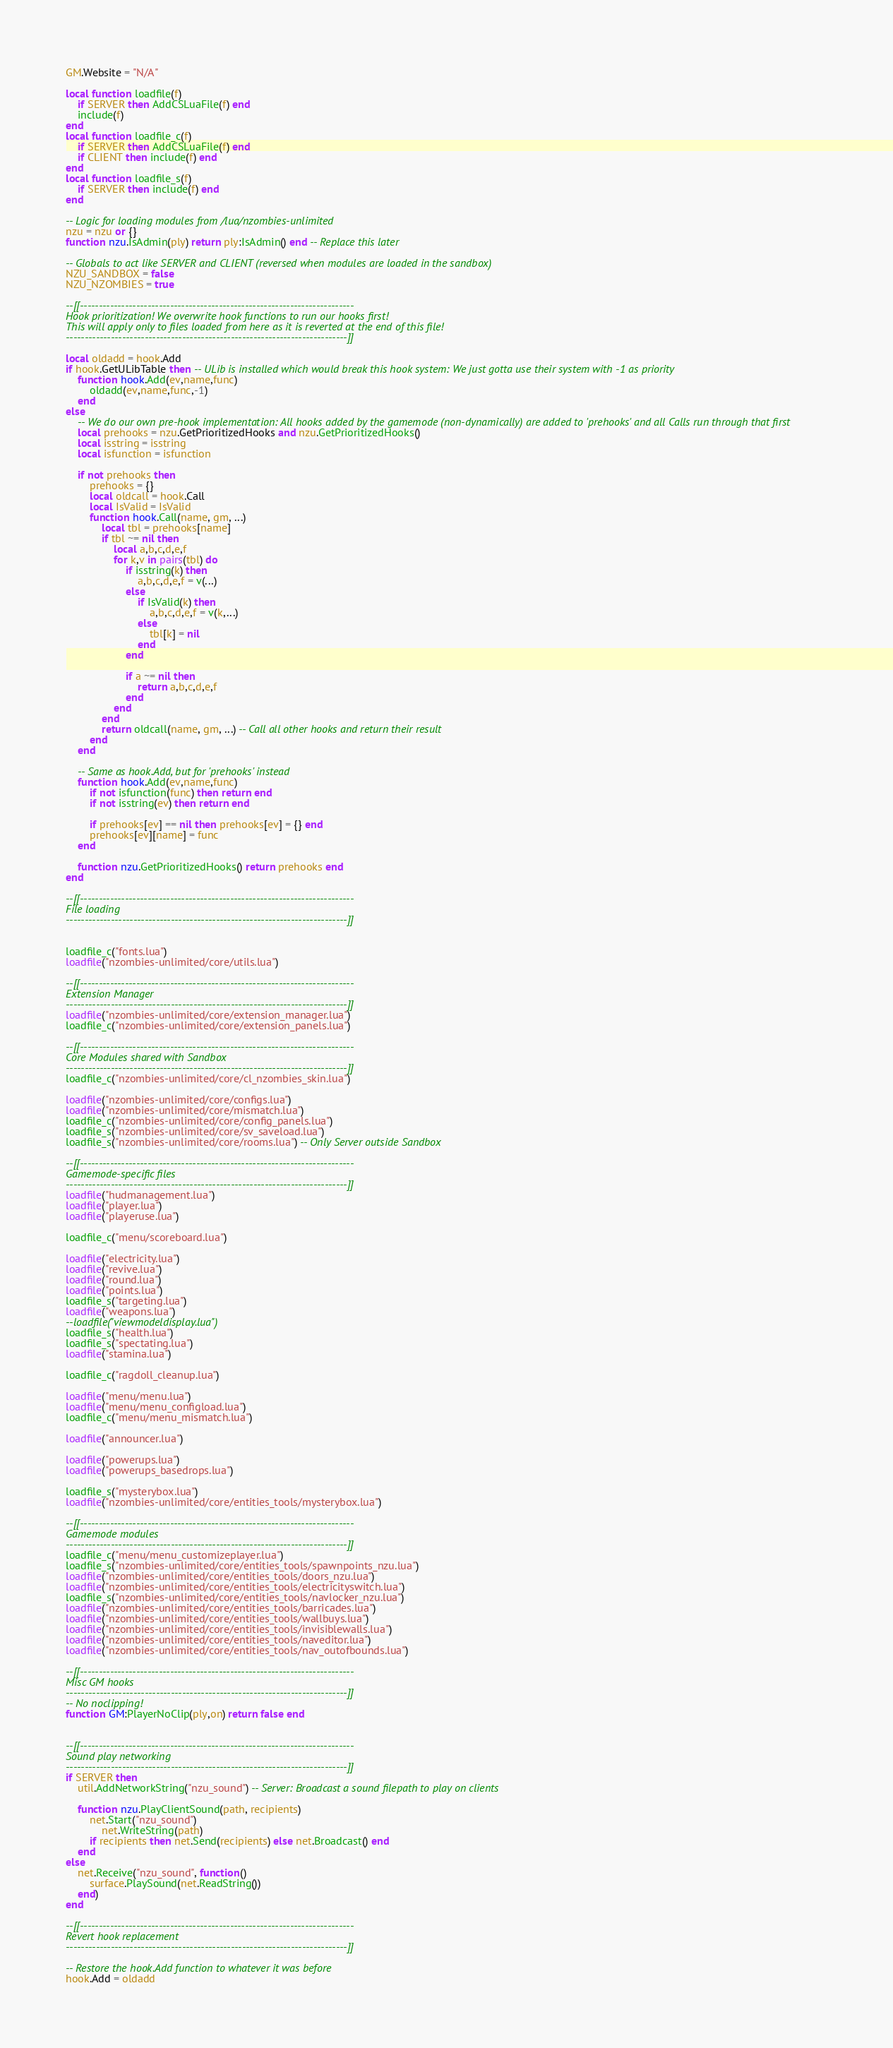<code> <loc_0><loc_0><loc_500><loc_500><_Lua_>GM.Website = "N/A"

local function loadfile(f)
	if SERVER then AddCSLuaFile(f) end
	include(f)
end
local function loadfile_c(f)
	if SERVER then AddCSLuaFile(f) end
	if CLIENT then include(f) end
end
local function loadfile_s(f)
	if SERVER then include(f) end
end

-- Logic for loading modules from /lua/nzombies-unlimited
nzu = nzu or {}
function nzu.IsAdmin(ply) return ply:IsAdmin() end -- Replace this later

-- Globals to act like SERVER and CLIENT (reversed when modules are loaded in the sandbox)
NZU_SANDBOX = false
NZU_NZOMBIES = true

--[[-------------------------------------------------------------------------
Hook prioritization! We overwrite hook functions to run our hooks first!
This will apply only to files loaded from here as it is reverted at the end of this file!
---------------------------------------------------------------------------]]

local oldadd = hook.Add
if hook.GetULibTable then -- ULib is installed which would break this hook system: We just gotta use their system with -1 as priority
	function hook.Add(ev,name,func)
		oldadd(ev,name,func,-1)
	end
else
	-- We do our own pre-hook implementation: All hooks added by the gamemode (non-dynamically) are added to 'prehooks' and all Calls run through that first
	local prehooks = nzu.GetPrioritizedHooks and nzu.GetPrioritizedHooks()
	local isstring = isstring
	local isfunction = isfunction

	if not prehooks then
		prehooks = {}
		local oldcall = hook.Call
		local IsValid = IsValid
		function hook.Call(name, gm, ...)
			local tbl = prehooks[name]
			if tbl ~= nil then
				local a,b,c,d,e,f
				for k,v in pairs(tbl) do
					if isstring(k) then
						a,b,c,d,e,f = v(...)
					else
						if IsValid(k) then
							a,b,c,d,e,f = v(k,...)
						else
							tbl[k] = nil
						end
					end

					if a ~= nil then
						return a,b,c,d,e,f
					end
				end
			end
			return oldcall(name, gm, ...) -- Call all other hooks and return their result
		end
	end

	-- Same as hook.Add, but for 'prehooks' instead
	function hook.Add(ev,name,func)
		if not isfunction(func) then return end
		if not isstring(ev) then return end

		if prehooks[ev] == nil then prehooks[ev] = {} end
		prehooks[ev][name] = func
	end

	function nzu.GetPrioritizedHooks() return prehooks end
end

--[[-------------------------------------------------------------------------
File loading
---------------------------------------------------------------------------]]


loadfile_c("fonts.lua")
loadfile("nzombies-unlimited/core/utils.lua")

--[[-------------------------------------------------------------------------
Extension Manager
---------------------------------------------------------------------------]]
loadfile("nzombies-unlimited/core/extension_manager.lua")
loadfile_c("nzombies-unlimited/core/extension_panels.lua")

--[[-------------------------------------------------------------------------
Core Modules shared with Sandbox
---------------------------------------------------------------------------]]
loadfile_c("nzombies-unlimited/core/cl_nzombies_skin.lua")

loadfile("nzombies-unlimited/core/configs.lua")
loadfile("nzombies-unlimited/core/mismatch.lua")
loadfile_c("nzombies-unlimited/core/config_panels.lua")
loadfile_s("nzombies-unlimited/core/sv_saveload.lua")
loadfile_s("nzombies-unlimited/core/rooms.lua") -- Only Server outside Sandbox

--[[-------------------------------------------------------------------------
Gamemode-specific files
---------------------------------------------------------------------------]]
loadfile("hudmanagement.lua")
loadfile("player.lua")
loadfile("playeruse.lua")

loadfile_c("menu/scoreboard.lua")

loadfile("electricity.lua")
loadfile("revive.lua")
loadfile("round.lua")
loadfile("points.lua")
loadfile_s("targeting.lua")
loadfile("weapons.lua")
--loadfile("viewmodeldisplay.lua")
loadfile_s("health.lua")
loadfile_s("spectating.lua")
loadfile("stamina.lua")

loadfile_c("ragdoll_cleanup.lua")

loadfile("menu/menu.lua")
loadfile("menu/menu_configload.lua")
loadfile_c("menu/menu_mismatch.lua")

loadfile("announcer.lua")

loadfile("powerups.lua")
loadfile("powerups_basedrops.lua")

loadfile_s("mysterybox.lua")
loadfile("nzombies-unlimited/core/entities_tools/mysterybox.lua")

--[[-------------------------------------------------------------------------
Gamemode modules
---------------------------------------------------------------------------]]
loadfile_c("menu/menu_customizeplayer.lua")
loadfile_s("nzombies-unlimited/core/entities_tools/spawnpoints_nzu.lua")
loadfile("nzombies-unlimited/core/entities_tools/doors_nzu.lua")
loadfile("nzombies-unlimited/core/entities_tools/electricityswitch.lua")
loadfile_s("nzombies-unlimited/core/entities_tools/navlocker_nzu.lua")
loadfile("nzombies-unlimited/core/entities_tools/barricades.lua")
loadfile("nzombies-unlimited/core/entities_tools/wallbuys.lua")
loadfile("nzombies-unlimited/core/entities_tools/invisiblewalls.lua")
loadfile("nzombies-unlimited/core/entities_tools/naveditor.lua")
loadfile("nzombies-unlimited/core/entities_tools/nav_outofbounds.lua")

--[[-------------------------------------------------------------------------
Misc GM hooks
---------------------------------------------------------------------------]]
-- No noclipping!
function GM:PlayerNoClip(ply,on) return false end


--[[-------------------------------------------------------------------------
Sound play networking
---------------------------------------------------------------------------]]
if SERVER then
	util.AddNetworkString("nzu_sound") -- Server: Broadcast a sound filepath to play on clients

	function nzu.PlayClientSound(path, recipients)
		net.Start("nzu_sound")
			net.WriteString(path)
		if recipients then net.Send(recipients) else net.Broadcast() end
	end
else
	net.Receive("nzu_sound", function()
		surface.PlaySound(net.ReadString())
	end)
end

--[[-------------------------------------------------------------------------
Revert hook replacement
---------------------------------------------------------------------------]]

-- Restore the hook.Add function to whatever it was before
hook.Add = oldadd</code> 